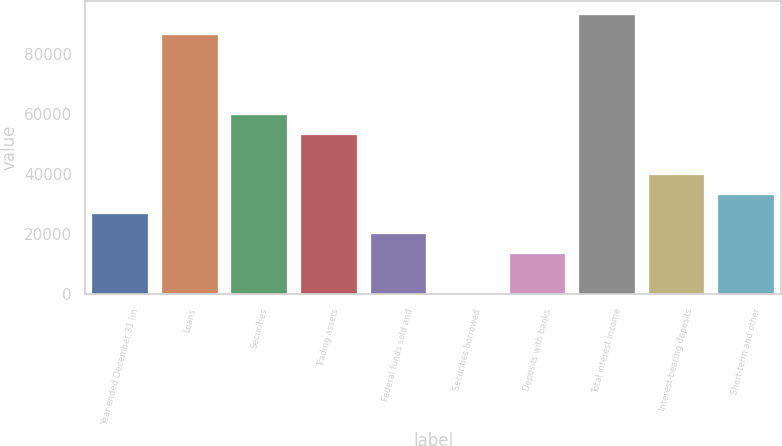<chart> <loc_0><loc_0><loc_500><loc_500><bar_chart><fcel>Year ended December 31 (in<fcel>Loans<fcel>Securities<fcel>Trading assets<fcel>Federal funds sold and<fcel>Securities borrowed<fcel>Deposits with banks<fcel>Total interest income<fcel>Interest-bearing deposits<fcel>Short-term and other<nl><fcel>26542.4<fcel>86253.8<fcel>59715.4<fcel>53080.8<fcel>19907.8<fcel>4<fcel>13273.2<fcel>92888.4<fcel>39811.6<fcel>33177<nl></chart> 